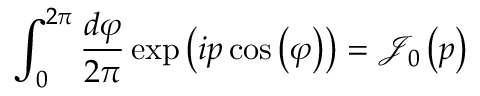<formula> <loc_0><loc_0><loc_500><loc_500>\int _ { 0 } ^ { 2 \pi } { \frac { d \varphi } { 2 \pi } } \exp \left ( i p \cos \left ( \varphi \right ) \right ) = { \mathcal { J } } _ { 0 } \left ( p \right )</formula> 